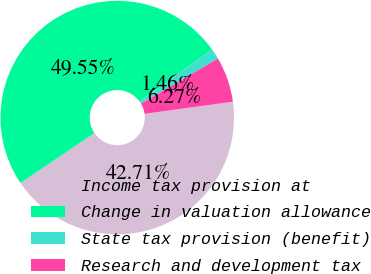Convert chart to OTSL. <chart><loc_0><loc_0><loc_500><loc_500><pie_chart><fcel>Income tax provision at<fcel>Change in valuation allowance<fcel>State tax provision (benefit)<fcel>Research and development tax<nl><fcel>42.71%<fcel>49.55%<fcel>1.46%<fcel>6.27%<nl></chart> 